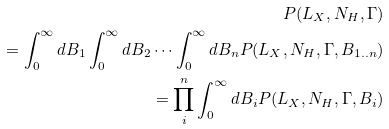<formula> <loc_0><loc_0><loc_500><loc_500>P ( L _ { X } , N _ { H } , \Gamma ) \\ = \int _ { 0 } ^ { \infty } d B _ { 1 } \int _ { 0 } ^ { \infty } d B _ { 2 } \cdots \int _ { 0 } ^ { \infty } d B _ { n } P ( L _ { X } , N _ { H } , \Gamma , B _ { 1 . . n } ) \\ = \prod _ { i } ^ { n } \int _ { 0 } ^ { \infty } d B _ { i } P ( L _ { X } , N _ { H } , \Gamma , B _ { i } )</formula> 